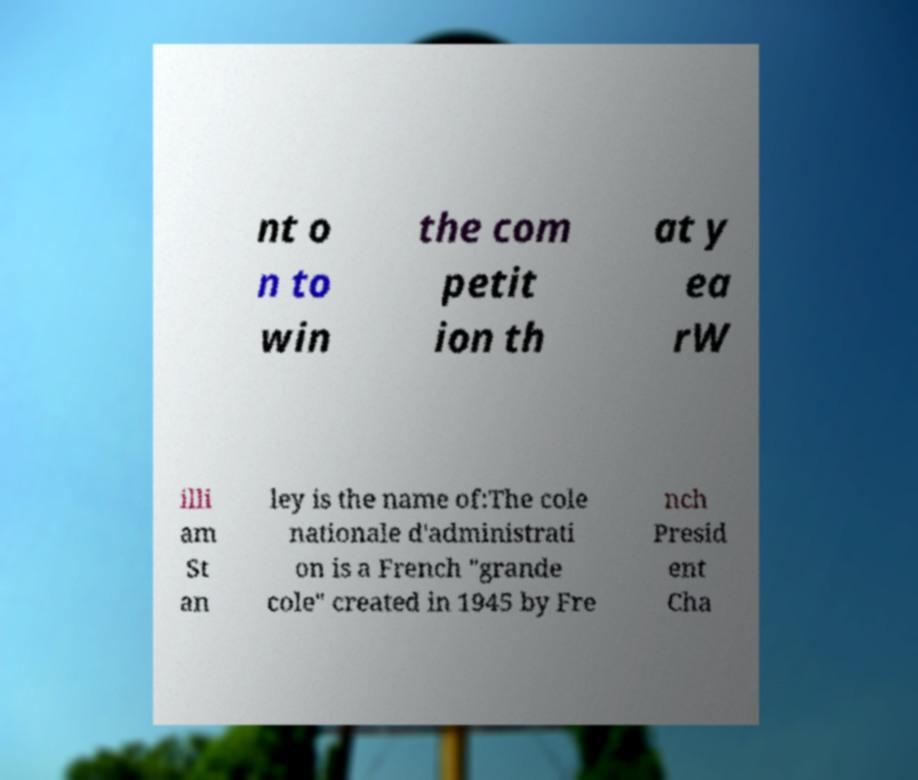There's text embedded in this image that I need extracted. Can you transcribe it verbatim? nt o n to win the com petit ion th at y ea rW illi am St an ley is the name of:The cole nationale d'administrati on is a French "grande cole" created in 1945 by Fre nch Presid ent Cha 